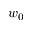<formula> <loc_0><loc_0><loc_500><loc_500>w _ { 0 }</formula> 